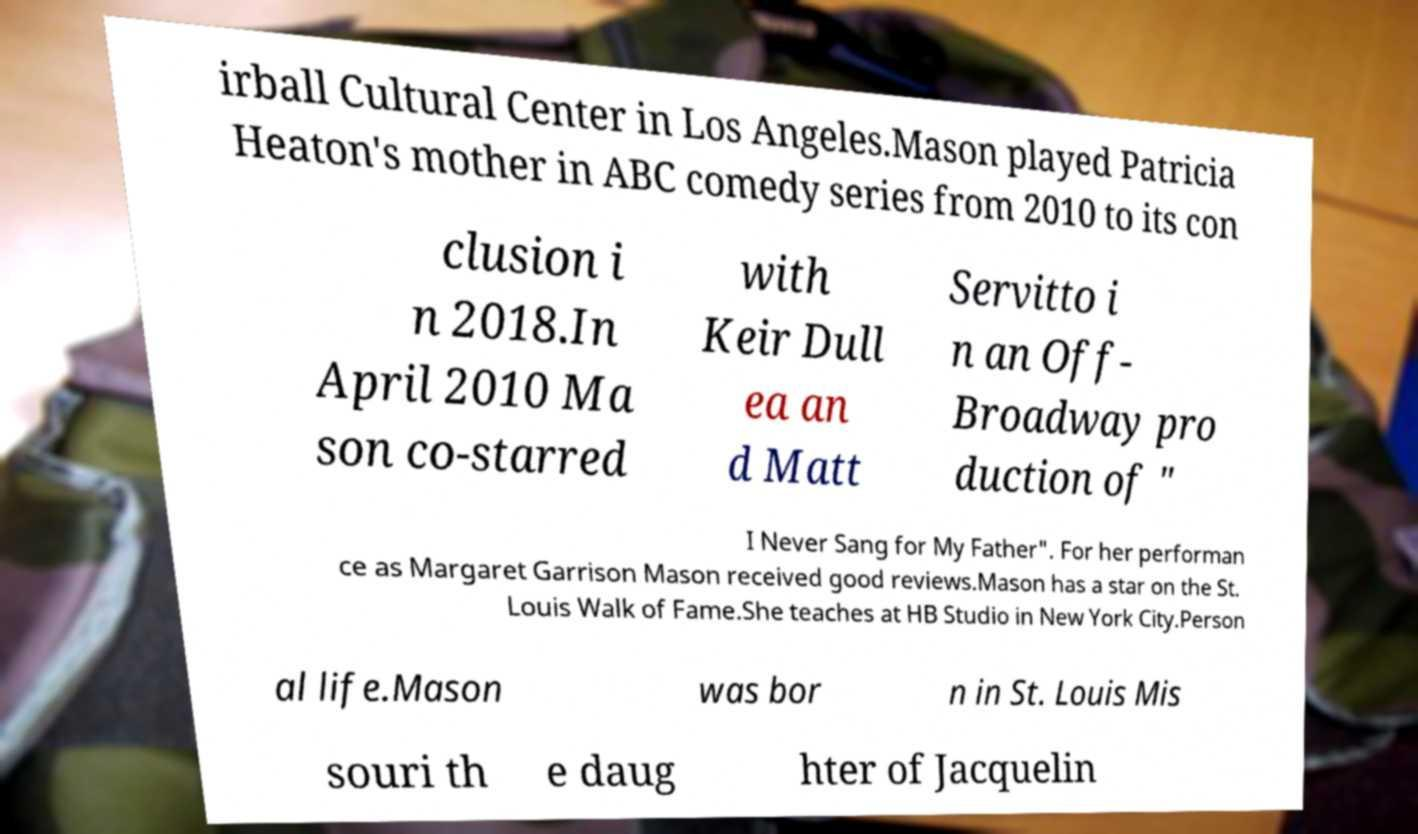Please identify and transcribe the text found in this image. irball Cultural Center in Los Angeles.Mason played Patricia Heaton's mother in ABC comedy series from 2010 to its con clusion i n 2018.In April 2010 Ma son co-starred with Keir Dull ea an d Matt Servitto i n an Off- Broadway pro duction of " I Never Sang for My Father". For her performan ce as Margaret Garrison Mason received good reviews.Mason has a star on the St. Louis Walk of Fame.She teaches at HB Studio in New York City.Person al life.Mason was bor n in St. Louis Mis souri th e daug hter of Jacquelin 